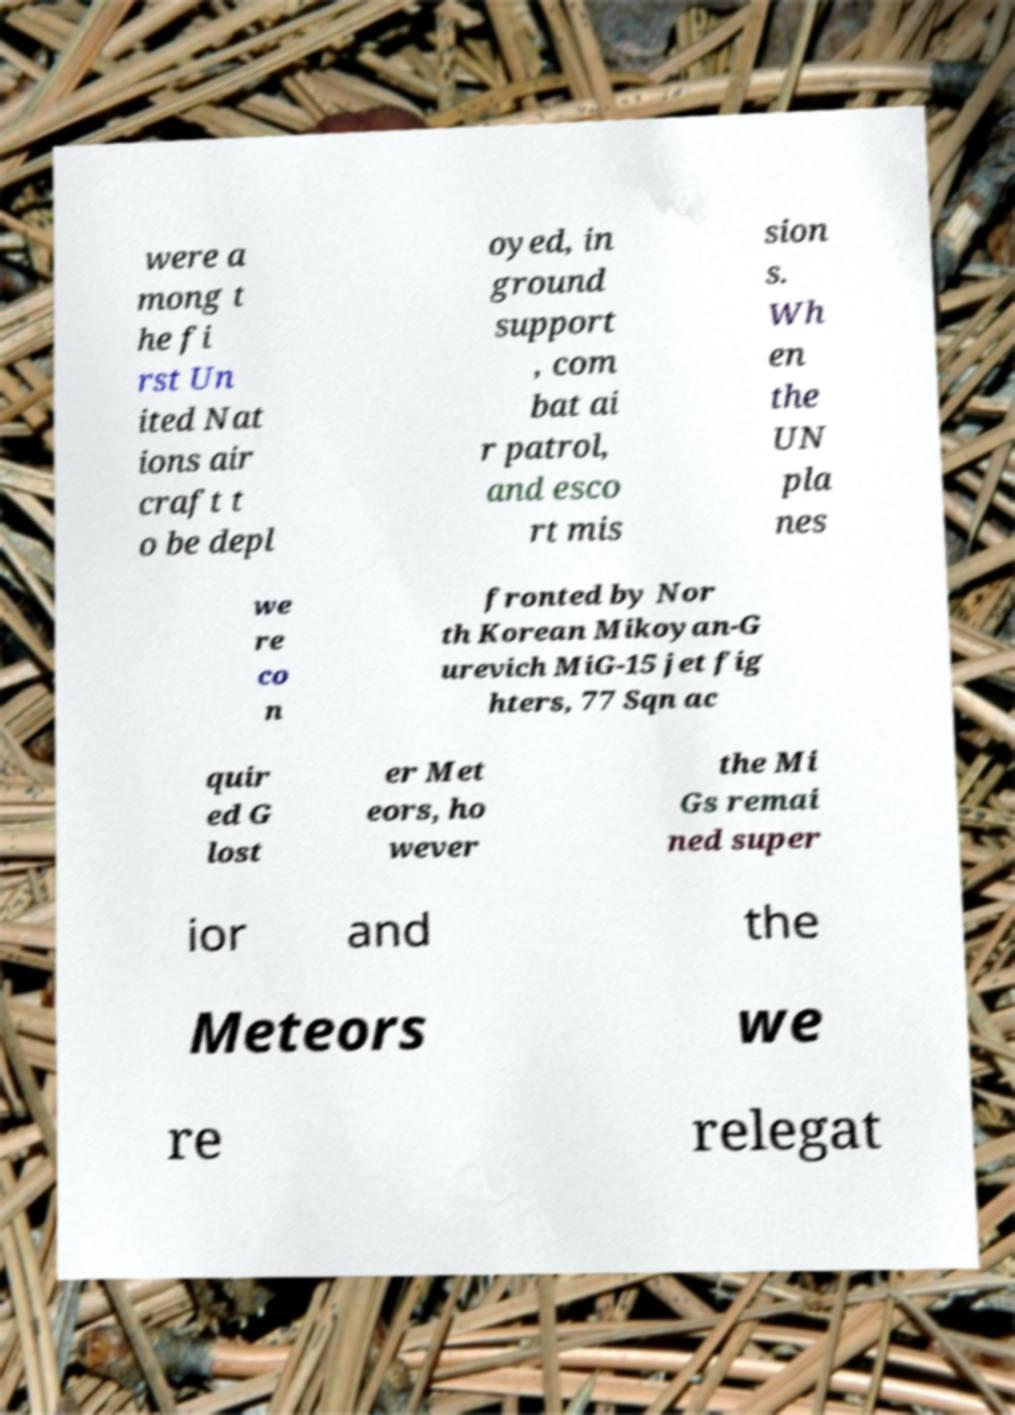Could you assist in decoding the text presented in this image and type it out clearly? were a mong t he fi rst Un ited Nat ions air craft t o be depl oyed, in ground support , com bat ai r patrol, and esco rt mis sion s. Wh en the UN pla nes we re co n fronted by Nor th Korean Mikoyan-G urevich MiG-15 jet fig hters, 77 Sqn ac quir ed G lost er Met eors, ho wever the Mi Gs remai ned super ior and the Meteors we re relegat 